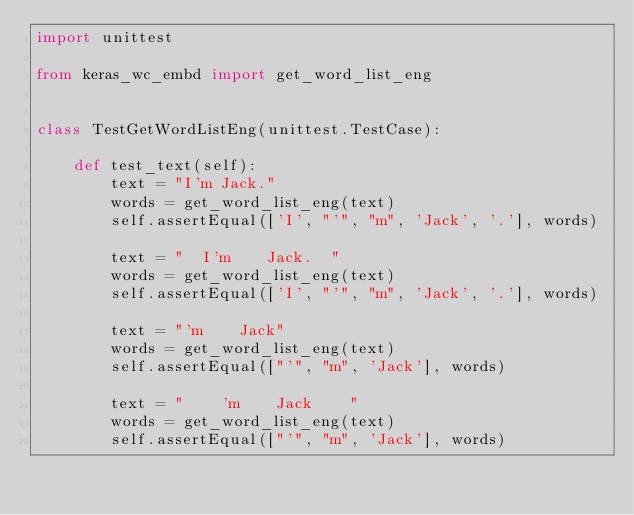Convert code to text. <code><loc_0><loc_0><loc_500><loc_500><_Python_>import unittest

from keras_wc_embd import get_word_list_eng


class TestGetWordListEng(unittest.TestCase):

    def test_text(self):
        text = "I'm Jack."
        words = get_word_list_eng(text)
        self.assertEqual(['I', "'", "m", 'Jack', '.'], words)

        text = "  I'm    Jack.  "
        words = get_word_list_eng(text)
        self.assertEqual(['I', "'", "m", 'Jack', '.'], words)

        text = "'m    Jack"
        words = get_word_list_eng(text)
        self.assertEqual(["'", "m", 'Jack'], words)

        text = "    'm    Jack    "
        words = get_word_list_eng(text)
        self.assertEqual(["'", "m", 'Jack'], words)
</code> 